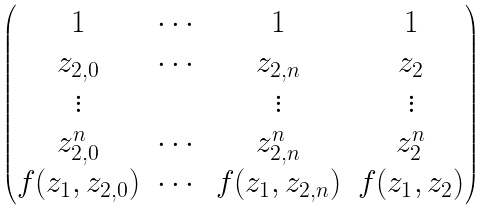<formula> <loc_0><loc_0><loc_500><loc_500>\begin{pmatrix} 1 & \cdots & 1 & 1 \\ z _ { 2 , 0 } & \cdots & z _ { 2 , n } & z _ { 2 } \\ \vdots & & \vdots & \vdots \\ z _ { 2 , 0 } ^ { n } & \cdots & z _ { 2 , n } ^ { n } & z _ { 2 } ^ { n } \\ f ( z _ { 1 } , z _ { 2 , 0 } ) & \cdots & f ( z _ { 1 } , z _ { 2 , n } ) & f ( z _ { 1 } , z _ { 2 } ) \end{pmatrix}</formula> 